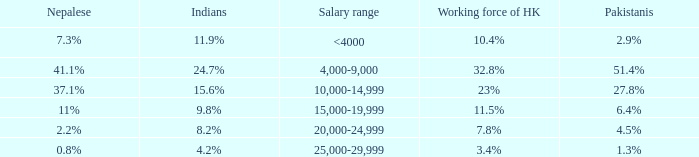Could you help me parse every detail presented in this table? {'header': ['Nepalese', 'Indians', 'Salary range', 'Working force of HK', 'Pakistanis'], 'rows': [['7.3%', '11.9%', '<4000', '10.4%', '2.9%'], ['41.1%', '24.7%', '4,000-9,000', '32.8%', '51.4%'], ['37.1%', '15.6%', '10,000-14,999', '23%', '27.8%'], ['11%', '9.8%', '15,000-19,999', '11.5%', '6.4%'], ['2.2%', '8.2%', '20,000-24,999', '7.8%', '4.5%'], ['0.8%', '4.2%', '25,000-29,999', '3.4%', '1.3%']]} If the nepalese is 37.1%, what is the working force of HK? 23%. 